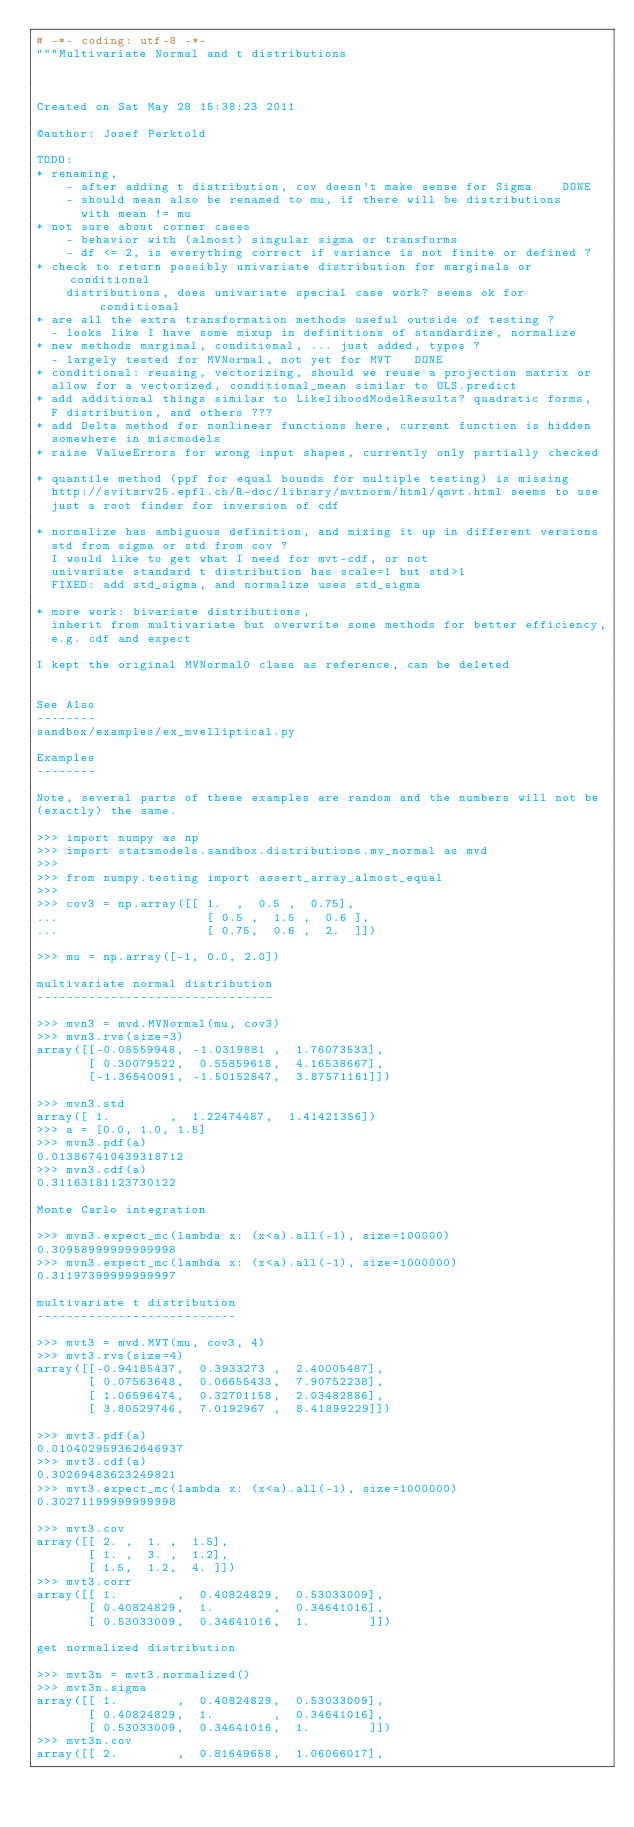<code> <loc_0><loc_0><loc_500><loc_500><_Python_># -*- coding: utf-8 -*-
"""Multivariate Normal and t distributions



Created on Sat May 28 15:38:23 2011

@author: Josef Perktold

TODO:
* renaming,
    - after adding t distribution, cov doesn't make sense for Sigma    DONE
    - should mean also be renamed to mu, if there will be distributions
      with mean != mu
* not sure about corner cases
    - behavior with (almost) singular sigma or transforms
    - df <= 2, is everything correct if variance is not finite or defined ?
* check to return possibly univariate distribution for marginals or conditional
    distributions, does univariate special case work? seems ok for conditional
* are all the extra transformation methods useful outside of testing ?
  - looks like I have some mixup in definitions of standardize, normalize
* new methods marginal, conditional, ... just added, typos ?
  - largely tested for MVNormal, not yet for MVT   DONE
* conditional: reusing, vectorizing, should we reuse a projection matrix or
  allow for a vectorized, conditional_mean similar to OLS.predict
* add additional things similar to LikelihoodModelResults? quadratic forms,
  F distribution, and others ???
* add Delta method for nonlinear functions here, current function is hidden
  somewhere in miscmodels
* raise ValueErrors for wrong input shapes, currently only partially checked

* quantile method (ppf for equal bounds for multiple testing) is missing
  http://svitsrv25.epfl.ch/R-doc/library/mvtnorm/html/qmvt.html seems to use
  just a root finder for inversion of cdf

* normalize has ambiguous definition, and mixing it up in different versions
  std from sigma or std from cov ?
  I would like to get what I need for mvt-cdf, or not
  univariate standard t distribution has scale=1 but std>1
  FIXED: add std_sigma, and normalize uses std_sigma

* more work: bivariate distributions,
  inherit from multivariate but overwrite some methods for better efficiency,
  e.g. cdf and expect

I kept the original MVNormal0 class as reference, can be deleted


See Also
--------
sandbox/examples/ex_mvelliptical.py

Examples
--------

Note, several parts of these examples are random and the numbers will not be
(exactly) the same.

>>> import numpy as np
>>> import statsmodels.sandbox.distributions.mv_normal as mvd
>>>
>>> from numpy.testing import assert_array_almost_equal
>>>
>>> cov3 = np.array([[ 1.  ,  0.5 ,  0.75],
...                    [ 0.5 ,  1.5 ,  0.6 ],
...                    [ 0.75,  0.6 ,  2.  ]])

>>> mu = np.array([-1, 0.0, 2.0])

multivariate normal distribution
--------------------------------

>>> mvn3 = mvd.MVNormal(mu, cov3)
>>> mvn3.rvs(size=3)
array([[-0.08559948, -1.0319881 ,  1.76073533],
       [ 0.30079522,  0.55859618,  4.16538667],
       [-1.36540091, -1.50152847,  3.87571161]])

>>> mvn3.std
array([ 1.        ,  1.22474487,  1.41421356])
>>> a = [0.0, 1.0, 1.5]
>>> mvn3.pdf(a)
0.013867410439318712
>>> mvn3.cdf(a)
0.31163181123730122

Monte Carlo integration

>>> mvn3.expect_mc(lambda x: (x<a).all(-1), size=100000)
0.30958999999999998
>>> mvn3.expect_mc(lambda x: (x<a).all(-1), size=1000000)
0.31197399999999997

multivariate t distribution
---------------------------

>>> mvt3 = mvd.MVT(mu, cov3, 4)
>>> mvt3.rvs(size=4)
array([[-0.94185437,  0.3933273 ,  2.40005487],
       [ 0.07563648,  0.06655433,  7.90752238],
       [ 1.06596474,  0.32701158,  2.03482886],
       [ 3.80529746,  7.0192967 ,  8.41899229]])

>>> mvt3.pdf(a)
0.010402959362646937
>>> mvt3.cdf(a)
0.30269483623249821
>>> mvt3.expect_mc(lambda x: (x<a).all(-1), size=1000000)
0.30271199999999998

>>> mvt3.cov
array([[ 2. ,  1. ,  1.5],
       [ 1. ,  3. ,  1.2],
       [ 1.5,  1.2,  4. ]])
>>> mvt3.corr
array([[ 1.        ,  0.40824829,  0.53033009],
       [ 0.40824829,  1.        ,  0.34641016],
       [ 0.53033009,  0.34641016,  1.        ]])

get normalized distribution

>>> mvt3n = mvt3.normalized()
>>> mvt3n.sigma
array([[ 1.        ,  0.40824829,  0.53033009],
       [ 0.40824829,  1.        ,  0.34641016],
       [ 0.53033009,  0.34641016,  1.        ]])
>>> mvt3n.cov
array([[ 2.        ,  0.81649658,  1.06066017],</code> 